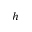Convert formula to latex. <formula><loc_0><loc_0><loc_500><loc_500>h</formula> 